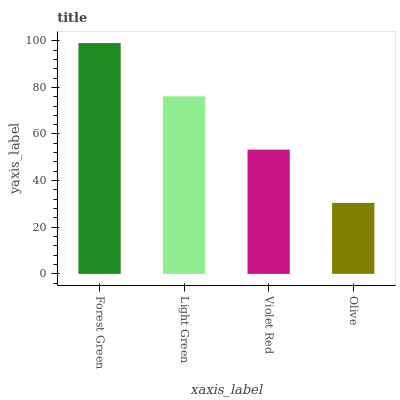Is Light Green the minimum?
Answer yes or no. No. Is Light Green the maximum?
Answer yes or no. No. Is Forest Green greater than Light Green?
Answer yes or no. Yes. Is Light Green less than Forest Green?
Answer yes or no. Yes. Is Light Green greater than Forest Green?
Answer yes or no. No. Is Forest Green less than Light Green?
Answer yes or no. No. Is Light Green the high median?
Answer yes or no. Yes. Is Violet Red the low median?
Answer yes or no. Yes. Is Olive the high median?
Answer yes or no. No. Is Light Green the low median?
Answer yes or no. No. 